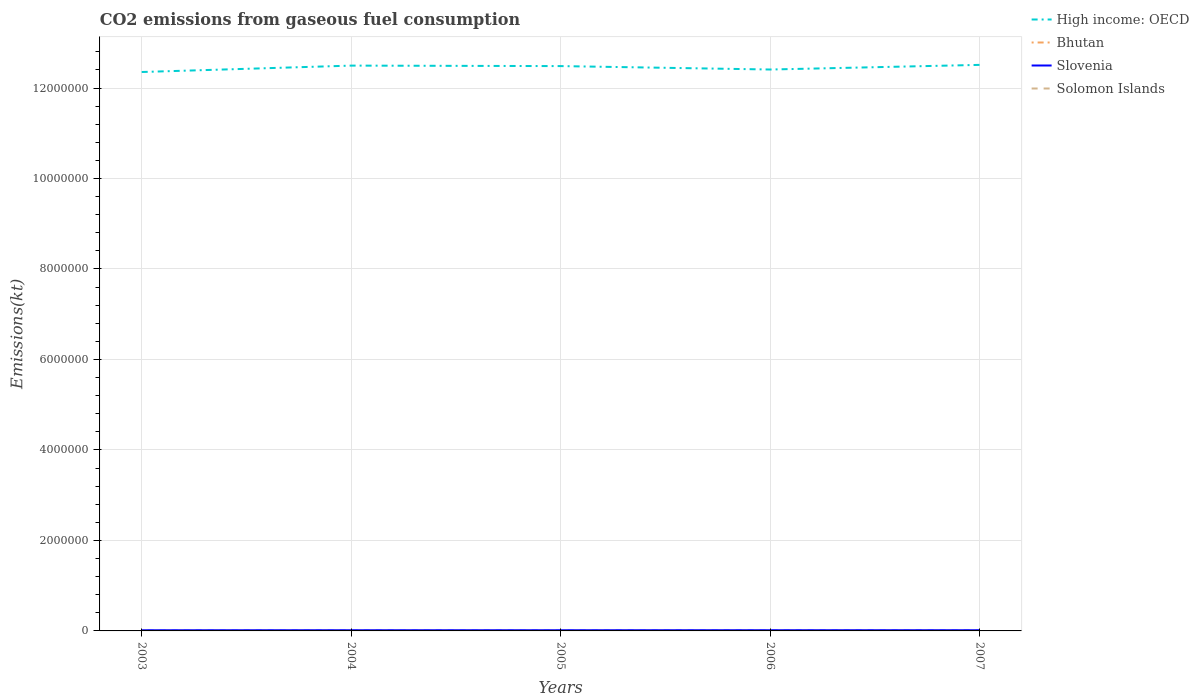How many different coloured lines are there?
Offer a very short reply. 4. Is the number of lines equal to the number of legend labels?
Provide a short and direct response. Yes. Across all years, what is the maximum amount of CO2 emitted in Solomon Islands?
Give a very brief answer. 179.68. In which year was the amount of CO2 emitted in Slovenia maximum?
Keep it short and to the point. 2003. What is the total amount of CO2 emitted in High income: OECD in the graph?
Your response must be concise. -1.03e+05. What is the difference between the highest and the second highest amount of CO2 emitted in Slovenia?
Keep it short and to the point. 733.4. What is the difference between the highest and the lowest amount of CO2 emitted in Solomon Islands?
Your answer should be compact. 1. How many years are there in the graph?
Provide a succinct answer. 5. Are the values on the major ticks of Y-axis written in scientific E-notation?
Provide a short and direct response. No. How are the legend labels stacked?
Provide a short and direct response. Vertical. What is the title of the graph?
Your answer should be compact. CO2 emissions from gaseous fuel consumption. Does "Albania" appear as one of the legend labels in the graph?
Your answer should be very brief. No. What is the label or title of the X-axis?
Offer a very short reply. Years. What is the label or title of the Y-axis?
Your answer should be compact. Emissions(kt). What is the Emissions(kt) in High income: OECD in 2003?
Ensure brevity in your answer.  1.24e+07. What is the Emissions(kt) in Bhutan in 2003?
Give a very brief answer. 377.7. What is the Emissions(kt) of Slovenia in 2003?
Offer a very short reply. 1.55e+04. What is the Emissions(kt) in Solomon Islands in 2003?
Provide a short and direct response. 179.68. What is the Emissions(kt) of High income: OECD in 2004?
Provide a short and direct response. 1.25e+07. What is the Emissions(kt) of Bhutan in 2004?
Provide a short and direct response. 308.03. What is the Emissions(kt) of Slovenia in 2004?
Keep it short and to the point. 1.57e+04. What is the Emissions(kt) in Solomon Islands in 2004?
Make the answer very short. 179.68. What is the Emissions(kt) in High income: OECD in 2005?
Keep it short and to the point. 1.25e+07. What is the Emissions(kt) in Bhutan in 2005?
Make the answer very short. 396.04. What is the Emissions(kt) in Slovenia in 2005?
Keep it short and to the point. 1.59e+04. What is the Emissions(kt) in Solomon Islands in 2005?
Your answer should be compact. 179.68. What is the Emissions(kt) of High income: OECD in 2006?
Give a very brief answer. 1.24e+07. What is the Emissions(kt) in Bhutan in 2006?
Provide a short and direct response. 392.37. What is the Emissions(kt) of Slovenia in 2006?
Your response must be concise. 1.62e+04. What is the Emissions(kt) of Solomon Islands in 2006?
Offer a very short reply. 179.68. What is the Emissions(kt) in High income: OECD in 2007?
Your response must be concise. 1.25e+07. What is the Emissions(kt) in Bhutan in 2007?
Make the answer very short. 392.37. What is the Emissions(kt) in Slovenia in 2007?
Offer a very short reply. 1.62e+04. What is the Emissions(kt) in Solomon Islands in 2007?
Offer a terse response. 190.68. Across all years, what is the maximum Emissions(kt) of High income: OECD?
Provide a succinct answer. 1.25e+07. Across all years, what is the maximum Emissions(kt) in Bhutan?
Your response must be concise. 396.04. Across all years, what is the maximum Emissions(kt) of Slovenia?
Your response must be concise. 1.62e+04. Across all years, what is the maximum Emissions(kt) in Solomon Islands?
Give a very brief answer. 190.68. Across all years, what is the minimum Emissions(kt) in High income: OECD?
Your answer should be very brief. 1.24e+07. Across all years, what is the minimum Emissions(kt) in Bhutan?
Provide a short and direct response. 308.03. Across all years, what is the minimum Emissions(kt) in Slovenia?
Provide a succinct answer. 1.55e+04. Across all years, what is the minimum Emissions(kt) of Solomon Islands?
Offer a very short reply. 179.68. What is the total Emissions(kt) in High income: OECD in the graph?
Your response must be concise. 6.23e+07. What is the total Emissions(kt) in Bhutan in the graph?
Give a very brief answer. 1866.5. What is the total Emissions(kt) in Slovenia in the graph?
Offer a terse response. 7.96e+04. What is the total Emissions(kt) of Solomon Islands in the graph?
Provide a succinct answer. 909.42. What is the difference between the Emissions(kt) of High income: OECD in 2003 and that in 2004?
Offer a very short reply. -1.41e+05. What is the difference between the Emissions(kt) in Bhutan in 2003 and that in 2004?
Ensure brevity in your answer.  69.67. What is the difference between the Emissions(kt) in Slovenia in 2003 and that in 2004?
Ensure brevity in your answer.  -234.69. What is the difference between the Emissions(kt) in Solomon Islands in 2003 and that in 2004?
Make the answer very short. 0. What is the difference between the Emissions(kt) in High income: OECD in 2003 and that in 2005?
Your response must be concise. -1.31e+05. What is the difference between the Emissions(kt) in Bhutan in 2003 and that in 2005?
Provide a short and direct response. -18.34. What is the difference between the Emissions(kt) in Slovenia in 2003 and that in 2005?
Ensure brevity in your answer.  -355.7. What is the difference between the Emissions(kt) of Solomon Islands in 2003 and that in 2005?
Make the answer very short. 0. What is the difference between the Emissions(kt) of High income: OECD in 2003 and that in 2006?
Offer a terse response. -5.51e+04. What is the difference between the Emissions(kt) in Bhutan in 2003 and that in 2006?
Make the answer very short. -14.67. What is the difference between the Emissions(kt) of Slovenia in 2003 and that in 2006?
Ensure brevity in your answer.  -733.4. What is the difference between the Emissions(kt) in High income: OECD in 2003 and that in 2007?
Your answer should be compact. -1.58e+05. What is the difference between the Emissions(kt) of Bhutan in 2003 and that in 2007?
Provide a succinct answer. -14.67. What is the difference between the Emissions(kt) of Slovenia in 2003 and that in 2007?
Your response must be concise. -733.4. What is the difference between the Emissions(kt) in Solomon Islands in 2003 and that in 2007?
Make the answer very short. -11. What is the difference between the Emissions(kt) of High income: OECD in 2004 and that in 2005?
Provide a short and direct response. 1.07e+04. What is the difference between the Emissions(kt) in Bhutan in 2004 and that in 2005?
Give a very brief answer. -88.01. What is the difference between the Emissions(kt) of Slovenia in 2004 and that in 2005?
Provide a short and direct response. -121.01. What is the difference between the Emissions(kt) in Solomon Islands in 2004 and that in 2005?
Your response must be concise. 0. What is the difference between the Emissions(kt) of High income: OECD in 2004 and that in 2006?
Provide a short and direct response. 8.64e+04. What is the difference between the Emissions(kt) of Bhutan in 2004 and that in 2006?
Provide a succinct answer. -84.34. What is the difference between the Emissions(kt) of Slovenia in 2004 and that in 2006?
Ensure brevity in your answer.  -498.71. What is the difference between the Emissions(kt) in Solomon Islands in 2004 and that in 2006?
Offer a very short reply. 0. What is the difference between the Emissions(kt) of High income: OECD in 2004 and that in 2007?
Your answer should be very brief. -1.61e+04. What is the difference between the Emissions(kt) of Bhutan in 2004 and that in 2007?
Offer a terse response. -84.34. What is the difference between the Emissions(kt) of Slovenia in 2004 and that in 2007?
Your answer should be compact. -498.71. What is the difference between the Emissions(kt) in Solomon Islands in 2004 and that in 2007?
Your response must be concise. -11. What is the difference between the Emissions(kt) of High income: OECD in 2005 and that in 2006?
Your answer should be compact. 7.57e+04. What is the difference between the Emissions(kt) in Bhutan in 2005 and that in 2006?
Your response must be concise. 3.67. What is the difference between the Emissions(kt) of Slovenia in 2005 and that in 2006?
Provide a succinct answer. -377.7. What is the difference between the Emissions(kt) of High income: OECD in 2005 and that in 2007?
Make the answer very short. -2.69e+04. What is the difference between the Emissions(kt) in Bhutan in 2005 and that in 2007?
Keep it short and to the point. 3.67. What is the difference between the Emissions(kt) in Slovenia in 2005 and that in 2007?
Offer a very short reply. -377.7. What is the difference between the Emissions(kt) in Solomon Islands in 2005 and that in 2007?
Offer a very short reply. -11. What is the difference between the Emissions(kt) of High income: OECD in 2006 and that in 2007?
Ensure brevity in your answer.  -1.03e+05. What is the difference between the Emissions(kt) of Bhutan in 2006 and that in 2007?
Your answer should be compact. 0. What is the difference between the Emissions(kt) in Slovenia in 2006 and that in 2007?
Your answer should be very brief. 0. What is the difference between the Emissions(kt) of Solomon Islands in 2006 and that in 2007?
Offer a very short reply. -11. What is the difference between the Emissions(kt) of High income: OECD in 2003 and the Emissions(kt) of Bhutan in 2004?
Provide a short and direct response. 1.24e+07. What is the difference between the Emissions(kt) in High income: OECD in 2003 and the Emissions(kt) in Slovenia in 2004?
Your answer should be compact. 1.23e+07. What is the difference between the Emissions(kt) of High income: OECD in 2003 and the Emissions(kt) of Solomon Islands in 2004?
Make the answer very short. 1.24e+07. What is the difference between the Emissions(kt) of Bhutan in 2003 and the Emissions(kt) of Slovenia in 2004?
Provide a succinct answer. -1.54e+04. What is the difference between the Emissions(kt) in Bhutan in 2003 and the Emissions(kt) in Solomon Islands in 2004?
Your answer should be very brief. 198.02. What is the difference between the Emissions(kt) in Slovenia in 2003 and the Emissions(kt) in Solomon Islands in 2004?
Offer a terse response. 1.53e+04. What is the difference between the Emissions(kt) in High income: OECD in 2003 and the Emissions(kt) in Bhutan in 2005?
Make the answer very short. 1.24e+07. What is the difference between the Emissions(kt) in High income: OECD in 2003 and the Emissions(kt) in Slovenia in 2005?
Make the answer very short. 1.23e+07. What is the difference between the Emissions(kt) of High income: OECD in 2003 and the Emissions(kt) of Solomon Islands in 2005?
Keep it short and to the point. 1.24e+07. What is the difference between the Emissions(kt) of Bhutan in 2003 and the Emissions(kt) of Slovenia in 2005?
Your response must be concise. -1.55e+04. What is the difference between the Emissions(kt) in Bhutan in 2003 and the Emissions(kt) in Solomon Islands in 2005?
Ensure brevity in your answer.  198.02. What is the difference between the Emissions(kt) in Slovenia in 2003 and the Emissions(kt) in Solomon Islands in 2005?
Make the answer very short. 1.53e+04. What is the difference between the Emissions(kt) of High income: OECD in 2003 and the Emissions(kt) of Bhutan in 2006?
Provide a short and direct response. 1.24e+07. What is the difference between the Emissions(kt) of High income: OECD in 2003 and the Emissions(kt) of Slovenia in 2006?
Ensure brevity in your answer.  1.23e+07. What is the difference between the Emissions(kt) in High income: OECD in 2003 and the Emissions(kt) in Solomon Islands in 2006?
Make the answer very short. 1.24e+07. What is the difference between the Emissions(kt) in Bhutan in 2003 and the Emissions(kt) in Slovenia in 2006?
Provide a short and direct response. -1.59e+04. What is the difference between the Emissions(kt) in Bhutan in 2003 and the Emissions(kt) in Solomon Islands in 2006?
Ensure brevity in your answer.  198.02. What is the difference between the Emissions(kt) in Slovenia in 2003 and the Emissions(kt) in Solomon Islands in 2006?
Offer a terse response. 1.53e+04. What is the difference between the Emissions(kt) of High income: OECD in 2003 and the Emissions(kt) of Bhutan in 2007?
Offer a terse response. 1.24e+07. What is the difference between the Emissions(kt) of High income: OECD in 2003 and the Emissions(kt) of Slovenia in 2007?
Make the answer very short. 1.23e+07. What is the difference between the Emissions(kt) of High income: OECD in 2003 and the Emissions(kt) of Solomon Islands in 2007?
Your answer should be very brief. 1.24e+07. What is the difference between the Emissions(kt) of Bhutan in 2003 and the Emissions(kt) of Slovenia in 2007?
Give a very brief answer. -1.59e+04. What is the difference between the Emissions(kt) of Bhutan in 2003 and the Emissions(kt) of Solomon Islands in 2007?
Offer a very short reply. 187.02. What is the difference between the Emissions(kt) in Slovenia in 2003 and the Emissions(kt) in Solomon Islands in 2007?
Offer a terse response. 1.53e+04. What is the difference between the Emissions(kt) in High income: OECD in 2004 and the Emissions(kt) in Bhutan in 2005?
Provide a succinct answer. 1.25e+07. What is the difference between the Emissions(kt) of High income: OECD in 2004 and the Emissions(kt) of Slovenia in 2005?
Offer a terse response. 1.25e+07. What is the difference between the Emissions(kt) of High income: OECD in 2004 and the Emissions(kt) of Solomon Islands in 2005?
Your answer should be very brief. 1.25e+07. What is the difference between the Emissions(kt) in Bhutan in 2004 and the Emissions(kt) in Slovenia in 2005?
Make the answer very short. -1.56e+04. What is the difference between the Emissions(kt) of Bhutan in 2004 and the Emissions(kt) of Solomon Islands in 2005?
Offer a terse response. 128.34. What is the difference between the Emissions(kt) of Slovenia in 2004 and the Emissions(kt) of Solomon Islands in 2005?
Your response must be concise. 1.56e+04. What is the difference between the Emissions(kt) in High income: OECD in 2004 and the Emissions(kt) in Bhutan in 2006?
Give a very brief answer. 1.25e+07. What is the difference between the Emissions(kt) of High income: OECD in 2004 and the Emissions(kt) of Slovenia in 2006?
Your response must be concise. 1.25e+07. What is the difference between the Emissions(kt) of High income: OECD in 2004 and the Emissions(kt) of Solomon Islands in 2006?
Your response must be concise. 1.25e+07. What is the difference between the Emissions(kt) in Bhutan in 2004 and the Emissions(kt) in Slovenia in 2006?
Provide a succinct answer. -1.59e+04. What is the difference between the Emissions(kt) of Bhutan in 2004 and the Emissions(kt) of Solomon Islands in 2006?
Make the answer very short. 128.34. What is the difference between the Emissions(kt) in Slovenia in 2004 and the Emissions(kt) in Solomon Islands in 2006?
Keep it short and to the point. 1.56e+04. What is the difference between the Emissions(kt) in High income: OECD in 2004 and the Emissions(kt) in Bhutan in 2007?
Provide a succinct answer. 1.25e+07. What is the difference between the Emissions(kt) of High income: OECD in 2004 and the Emissions(kt) of Slovenia in 2007?
Provide a succinct answer. 1.25e+07. What is the difference between the Emissions(kt) of High income: OECD in 2004 and the Emissions(kt) of Solomon Islands in 2007?
Keep it short and to the point. 1.25e+07. What is the difference between the Emissions(kt) in Bhutan in 2004 and the Emissions(kt) in Slovenia in 2007?
Offer a terse response. -1.59e+04. What is the difference between the Emissions(kt) of Bhutan in 2004 and the Emissions(kt) of Solomon Islands in 2007?
Offer a terse response. 117.34. What is the difference between the Emissions(kt) in Slovenia in 2004 and the Emissions(kt) in Solomon Islands in 2007?
Provide a short and direct response. 1.56e+04. What is the difference between the Emissions(kt) in High income: OECD in 2005 and the Emissions(kt) in Bhutan in 2006?
Your answer should be very brief. 1.25e+07. What is the difference between the Emissions(kt) in High income: OECD in 2005 and the Emissions(kt) in Slovenia in 2006?
Ensure brevity in your answer.  1.25e+07. What is the difference between the Emissions(kt) in High income: OECD in 2005 and the Emissions(kt) in Solomon Islands in 2006?
Your answer should be compact. 1.25e+07. What is the difference between the Emissions(kt) of Bhutan in 2005 and the Emissions(kt) of Slovenia in 2006?
Make the answer very short. -1.58e+04. What is the difference between the Emissions(kt) of Bhutan in 2005 and the Emissions(kt) of Solomon Islands in 2006?
Give a very brief answer. 216.35. What is the difference between the Emissions(kt) in Slovenia in 2005 and the Emissions(kt) in Solomon Islands in 2006?
Your answer should be very brief. 1.57e+04. What is the difference between the Emissions(kt) in High income: OECD in 2005 and the Emissions(kt) in Bhutan in 2007?
Provide a succinct answer. 1.25e+07. What is the difference between the Emissions(kt) of High income: OECD in 2005 and the Emissions(kt) of Slovenia in 2007?
Offer a terse response. 1.25e+07. What is the difference between the Emissions(kt) of High income: OECD in 2005 and the Emissions(kt) of Solomon Islands in 2007?
Your answer should be very brief. 1.25e+07. What is the difference between the Emissions(kt) of Bhutan in 2005 and the Emissions(kt) of Slovenia in 2007?
Provide a short and direct response. -1.58e+04. What is the difference between the Emissions(kt) of Bhutan in 2005 and the Emissions(kt) of Solomon Islands in 2007?
Offer a terse response. 205.35. What is the difference between the Emissions(kt) in Slovenia in 2005 and the Emissions(kt) in Solomon Islands in 2007?
Make the answer very short. 1.57e+04. What is the difference between the Emissions(kt) in High income: OECD in 2006 and the Emissions(kt) in Bhutan in 2007?
Give a very brief answer. 1.24e+07. What is the difference between the Emissions(kt) of High income: OECD in 2006 and the Emissions(kt) of Slovenia in 2007?
Your answer should be compact. 1.24e+07. What is the difference between the Emissions(kt) of High income: OECD in 2006 and the Emissions(kt) of Solomon Islands in 2007?
Offer a very short reply. 1.24e+07. What is the difference between the Emissions(kt) in Bhutan in 2006 and the Emissions(kt) in Slovenia in 2007?
Your answer should be very brief. -1.59e+04. What is the difference between the Emissions(kt) in Bhutan in 2006 and the Emissions(kt) in Solomon Islands in 2007?
Offer a terse response. 201.69. What is the difference between the Emissions(kt) in Slovenia in 2006 and the Emissions(kt) in Solomon Islands in 2007?
Keep it short and to the point. 1.61e+04. What is the average Emissions(kt) in High income: OECD per year?
Offer a very short reply. 1.25e+07. What is the average Emissions(kt) of Bhutan per year?
Keep it short and to the point. 373.3. What is the average Emissions(kt) of Slovenia per year?
Your answer should be very brief. 1.59e+04. What is the average Emissions(kt) in Solomon Islands per year?
Provide a succinct answer. 181.88. In the year 2003, what is the difference between the Emissions(kt) in High income: OECD and Emissions(kt) in Bhutan?
Your response must be concise. 1.24e+07. In the year 2003, what is the difference between the Emissions(kt) in High income: OECD and Emissions(kt) in Slovenia?
Your answer should be compact. 1.23e+07. In the year 2003, what is the difference between the Emissions(kt) in High income: OECD and Emissions(kt) in Solomon Islands?
Make the answer very short. 1.24e+07. In the year 2003, what is the difference between the Emissions(kt) in Bhutan and Emissions(kt) in Slovenia?
Offer a very short reply. -1.51e+04. In the year 2003, what is the difference between the Emissions(kt) of Bhutan and Emissions(kt) of Solomon Islands?
Keep it short and to the point. 198.02. In the year 2003, what is the difference between the Emissions(kt) of Slovenia and Emissions(kt) of Solomon Islands?
Offer a very short reply. 1.53e+04. In the year 2004, what is the difference between the Emissions(kt) in High income: OECD and Emissions(kt) in Bhutan?
Your response must be concise. 1.25e+07. In the year 2004, what is the difference between the Emissions(kt) of High income: OECD and Emissions(kt) of Slovenia?
Ensure brevity in your answer.  1.25e+07. In the year 2004, what is the difference between the Emissions(kt) in High income: OECD and Emissions(kt) in Solomon Islands?
Give a very brief answer. 1.25e+07. In the year 2004, what is the difference between the Emissions(kt) in Bhutan and Emissions(kt) in Slovenia?
Make the answer very short. -1.54e+04. In the year 2004, what is the difference between the Emissions(kt) of Bhutan and Emissions(kt) of Solomon Islands?
Provide a succinct answer. 128.34. In the year 2004, what is the difference between the Emissions(kt) of Slovenia and Emissions(kt) of Solomon Islands?
Provide a succinct answer. 1.56e+04. In the year 2005, what is the difference between the Emissions(kt) of High income: OECD and Emissions(kt) of Bhutan?
Your answer should be very brief. 1.25e+07. In the year 2005, what is the difference between the Emissions(kt) in High income: OECD and Emissions(kt) in Slovenia?
Offer a very short reply. 1.25e+07. In the year 2005, what is the difference between the Emissions(kt) of High income: OECD and Emissions(kt) of Solomon Islands?
Offer a terse response. 1.25e+07. In the year 2005, what is the difference between the Emissions(kt) in Bhutan and Emissions(kt) in Slovenia?
Keep it short and to the point. -1.55e+04. In the year 2005, what is the difference between the Emissions(kt) of Bhutan and Emissions(kt) of Solomon Islands?
Keep it short and to the point. 216.35. In the year 2005, what is the difference between the Emissions(kt) in Slovenia and Emissions(kt) in Solomon Islands?
Provide a short and direct response. 1.57e+04. In the year 2006, what is the difference between the Emissions(kt) in High income: OECD and Emissions(kt) in Bhutan?
Keep it short and to the point. 1.24e+07. In the year 2006, what is the difference between the Emissions(kt) of High income: OECD and Emissions(kt) of Slovenia?
Offer a terse response. 1.24e+07. In the year 2006, what is the difference between the Emissions(kt) of High income: OECD and Emissions(kt) of Solomon Islands?
Your response must be concise. 1.24e+07. In the year 2006, what is the difference between the Emissions(kt) of Bhutan and Emissions(kt) of Slovenia?
Your answer should be very brief. -1.59e+04. In the year 2006, what is the difference between the Emissions(kt) of Bhutan and Emissions(kt) of Solomon Islands?
Your answer should be very brief. 212.69. In the year 2006, what is the difference between the Emissions(kt) of Slovenia and Emissions(kt) of Solomon Islands?
Make the answer very short. 1.61e+04. In the year 2007, what is the difference between the Emissions(kt) of High income: OECD and Emissions(kt) of Bhutan?
Provide a short and direct response. 1.25e+07. In the year 2007, what is the difference between the Emissions(kt) in High income: OECD and Emissions(kt) in Slovenia?
Give a very brief answer. 1.25e+07. In the year 2007, what is the difference between the Emissions(kt) in High income: OECD and Emissions(kt) in Solomon Islands?
Offer a very short reply. 1.25e+07. In the year 2007, what is the difference between the Emissions(kt) in Bhutan and Emissions(kt) in Slovenia?
Your answer should be very brief. -1.59e+04. In the year 2007, what is the difference between the Emissions(kt) of Bhutan and Emissions(kt) of Solomon Islands?
Your answer should be compact. 201.69. In the year 2007, what is the difference between the Emissions(kt) of Slovenia and Emissions(kt) of Solomon Islands?
Keep it short and to the point. 1.61e+04. What is the ratio of the Emissions(kt) in High income: OECD in 2003 to that in 2004?
Provide a succinct answer. 0.99. What is the ratio of the Emissions(kt) of Bhutan in 2003 to that in 2004?
Your answer should be compact. 1.23. What is the ratio of the Emissions(kt) in Slovenia in 2003 to that in 2004?
Your answer should be very brief. 0.99. What is the ratio of the Emissions(kt) of High income: OECD in 2003 to that in 2005?
Provide a short and direct response. 0.99. What is the ratio of the Emissions(kt) in Bhutan in 2003 to that in 2005?
Offer a very short reply. 0.95. What is the ratio of the Emissions(kt) of Slovenia in 2003 to that in 2005?
Keep it short and to the point. 0.98. What is the ratio of the Emissions(kt) in Solomon Islands in 2003 to that in 2005?
Give a very brief answer. 1. What is the ratio of the Emissions(kt) in Bhutan in 2003 to that in 2006?
Provide a succinct answer. 0.96. What is the ratio of the Emissions(kt) of Slovenia in 2003 to that in 2006?
Your response must be concise. 0.95. What is the ratio of the Emissions(kt) of Solomon Islands in 2003 to that in 2006?
Make the answer very short. 1. What is the ratio of the Emissions(kt) in High income: OECD in 2003 to that in 2007?
Provide a succinct answer. 0.99. What is the ratio of the Emissions(kt) in Bhutan in 2003 to that in 2007?
Provide a short and direct response. 0.96. What is the ratio of the Emissions(kt) in Slovenia in 2003 to that in 2007?
Ensure brevity in your answer.  0.95. What is the ratio of the Emissions(kt) of Solomon Islands in 2003 to that in 2007?
Your answer should be compact. 0.94. What is the ratio of the Emissions(kt) in Bhutan in 2004 to that in 2005?
Your answer should be compact. 0.78. What is the ratio of the Emissions(kt) of Solomon Islands in 2004 to that in 2005?
Your answer should be very brief. 1. What is the ratio of the Emissions(kt) in Bhutan in 2004 to that in 2006?
Keep it short and to the point. 0.79. What is the ratio of the Emissions(kt) in Slovenia in 2004 to that in 2006?
Offer a terse response. 0.97. What is the ratio of the Emissions(kt) of Solomon Islands in 2004 to that in 2006?
Give a very brief answer. 1. What is the ratio of the Emissions(kt) in High income: OECD in 2004 to that in 2007?
Provide a short and direct response. 1. What is the ratio of the Emissions(kt) of Bhutan in 2004 to that in 2007?
Provide a short and direct response. 0.79. What is the ratio of the Emissions(kt) in Slovenia in 2004 to that in 2007?
Offer a very short reply. 0.97. What is the ratio of the Emissions(kt) of Solomon Islands in 2004 to that in 2007?
Ensure brevity in your answer.  0.94. What is the ratio of the Emissions(kt) in Bhutan in 2005 to that in 2006?
Provide a succinct answer. 1.01. What is the ratio of the Emissions(kt) of Slovenia in 2005 to that in 2006?
Make the answer very short. 0.98. What is the ratio of the Emissions(kt) in High income: OECD in 2005 to that in 2007?
Make the answer very short. 1. What is the ratio of the Emissions(kt) in Bhutan in 2005 to that in 2007?
Provide a succinct answer. 1.01. What is the ratio of the Emissions(kt) of Slovenia in 2005 to that in 2007?
Provide a succinct answer. 0.98. What is the ratio of the Emissions(kt) of Solomon Islands in 2005 to that in 2007?
Provide a succinct answer. 0.94. What is the ratio of the Emissions(kt) of High income: OECD in 2006 to that in 2007?
Your answer should be very brief. 0.99. What is the ratio of the Emissions(kt) of Bhutan in 2006 to that in 2007?
Provide a short and direct response. 1. What is the ratio of the Emissions(kt) of Solomon Islands in 2006 to that in 2007?
Your answer should be very brief. 0.94. What is the difference between the highest and the second highest Emissions(kt) of High income: OECD?
Your answer should be compact. 1.61e+04. What is the difference between the highest and the second highest Emissions(kt) in Bhutan?
Ensure brevity in your answer.  3.67. What is the difference between the highest and the second highest Emissions(kt) of Slovenia?
Ensure brevity in your answer.  0. What is the difference between the highest and the second highest Emissions(kt) in Solomon Islands?
Give a very brief answer. 11. What is the difference between the highest and the lowest Emissions(kt) of High income: OECD?
Provide a succinct answer. 1.58e+05. What is the difference between the highest and the lowest Emissions(kt) in Bhutan?
Offer a very short reply. 88.01. What is the difference between the highest and the lowest Emissions(kt) of Slovenia?
Your answer should be very brief. 733.4. What is the difference between the highest and the lowest Emissions(kt) of Solomon Islands?
Your response must be concise. 11. 